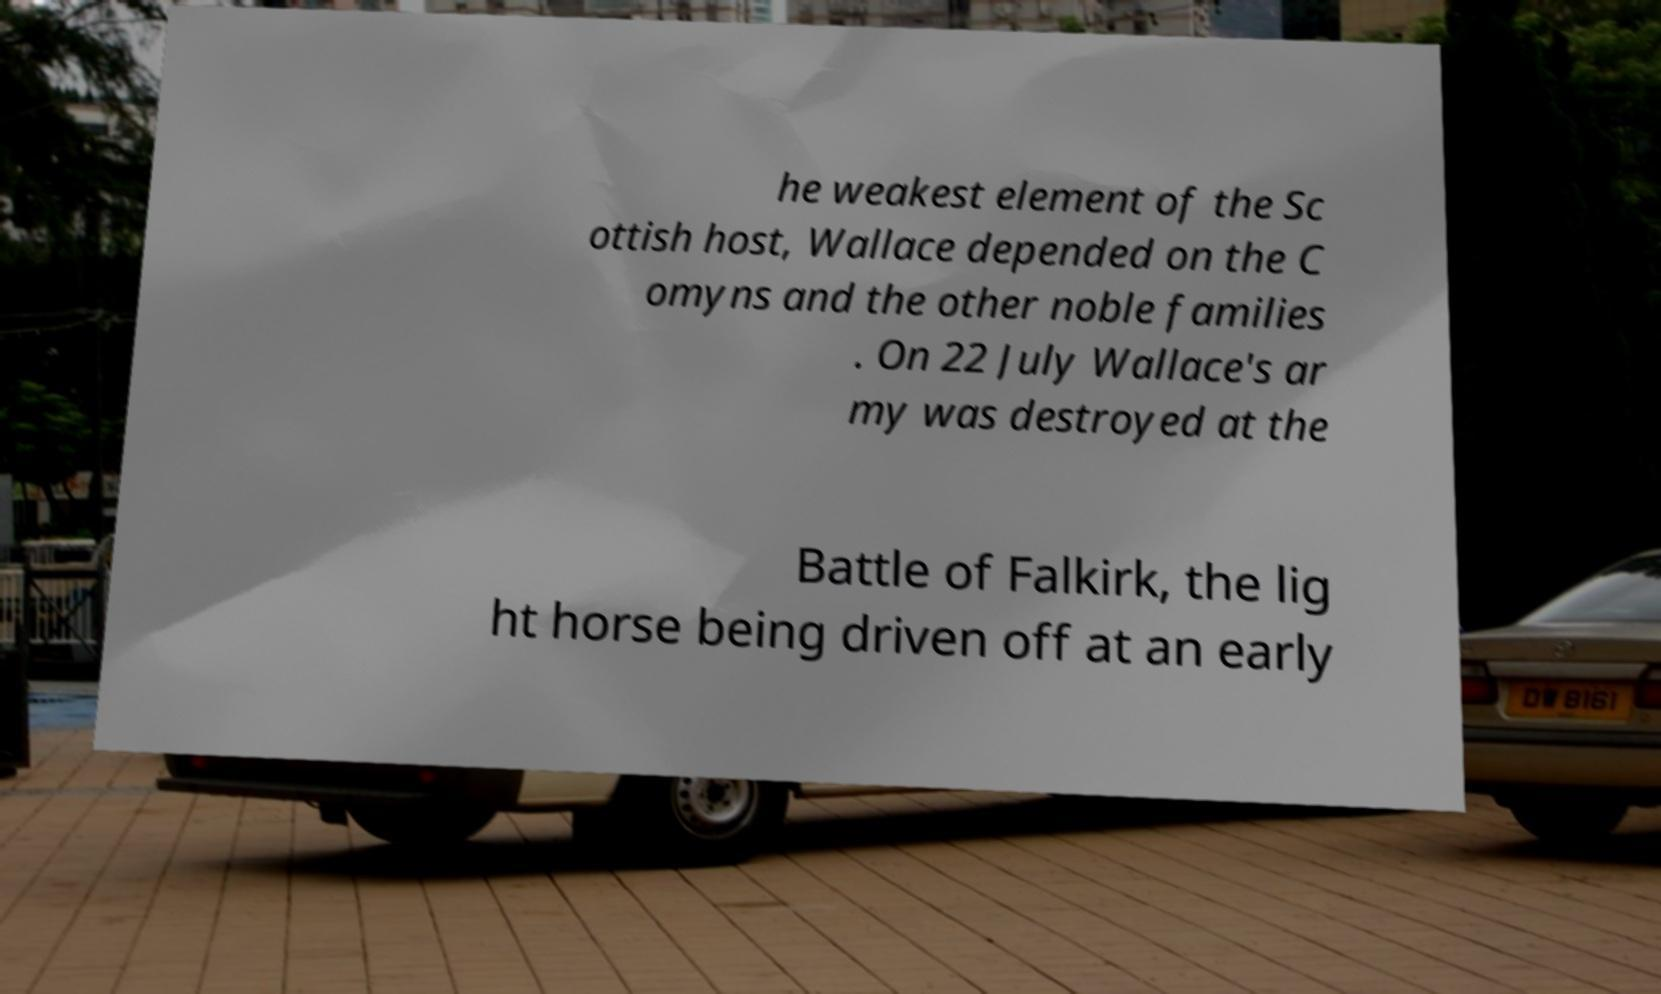Could you assist in decoding the text presented in this image and type it out clearly? he weakest element of the Sc ottish host, Wallace depended on the C omyns and the other noble families . On 22 July Wallace's ar my was destroyed at the Battle of Falkirk, the lig ht horse being driven off at an early 